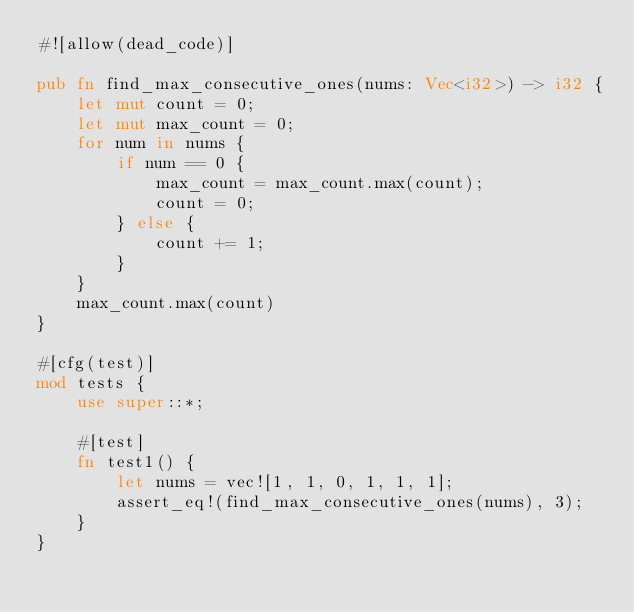<code> <loc_0><loc_0><loc_500><loc_500><_Rust_>#![allow(dead_code)]

pub fn find_max_consecutive_ones(nums: Vec<i32>) -> i32 {
    let mut count = 0;
    let mut max_count = 0;
    for num in nums {
        if num == 0 {
            max_count = max_count.max(count);
            count = 0;
        } else {
            count += 1;
        }
    }
    max_count.max(count)
}

#[cfg(test)]
mod tests {
    use super::*;

    #[test]
    fn test1() {
        let nums = vec![1, 1, 0, 1, 1, 1];
        assert_eq!(find_max_consecutive_ones(nums), 3);
    }
}
</code> 